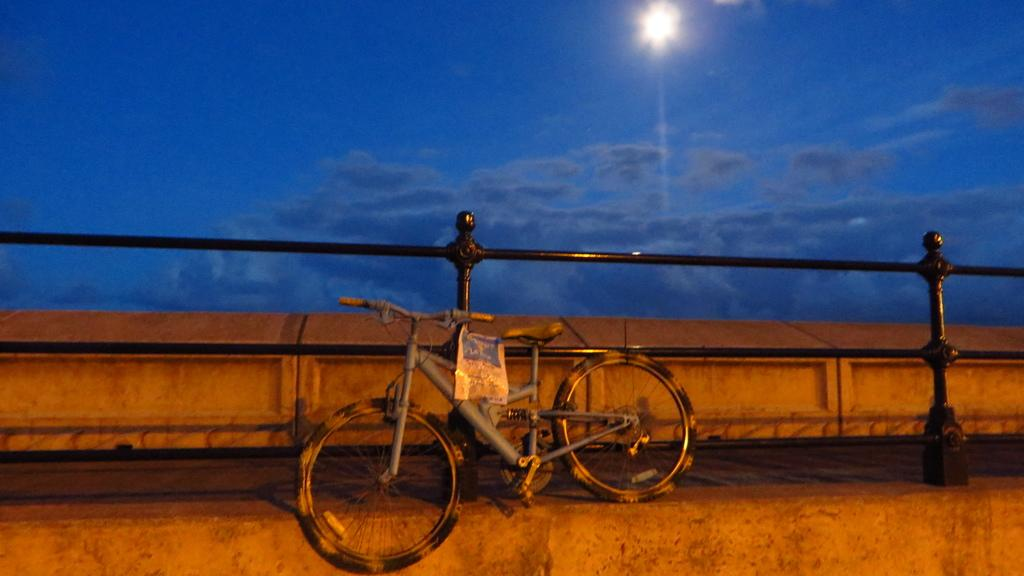What is the main object in the image? There is a bicycle in the image. What else can be seen in the image besides the bicycle? There is a poster, fencing, a path, and the sky visible in the image. Can you describe the sky in the image? The sky is visible in the image, and there are clouds and the moon present. What might the path be used for in the image? The path might be used for walking or biking in the image. What time does the clock show in the image? There is no clock present in the image. Can you tell me how the drain is functioning in the image? There is no drain present in the image. 